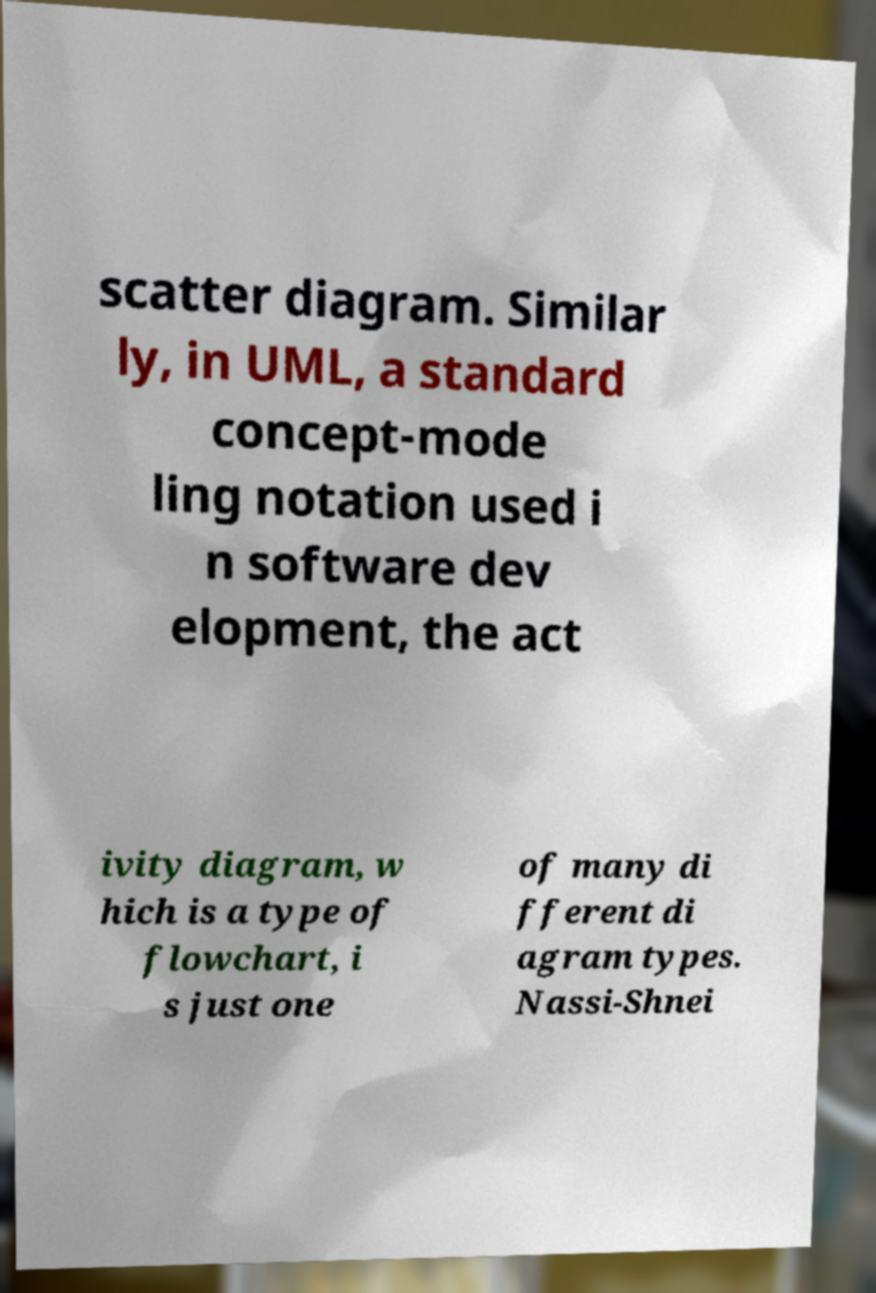I need the written content from this picture converted into text. Can you do that? scatter diagram. Similar ly, in UML, a standard concept-mode ling notation used i n software dev elopment, the act ivity diagram, w hich is a type of flowchart, i s just one of many di fferent di agram types. Nassi-Shnei 